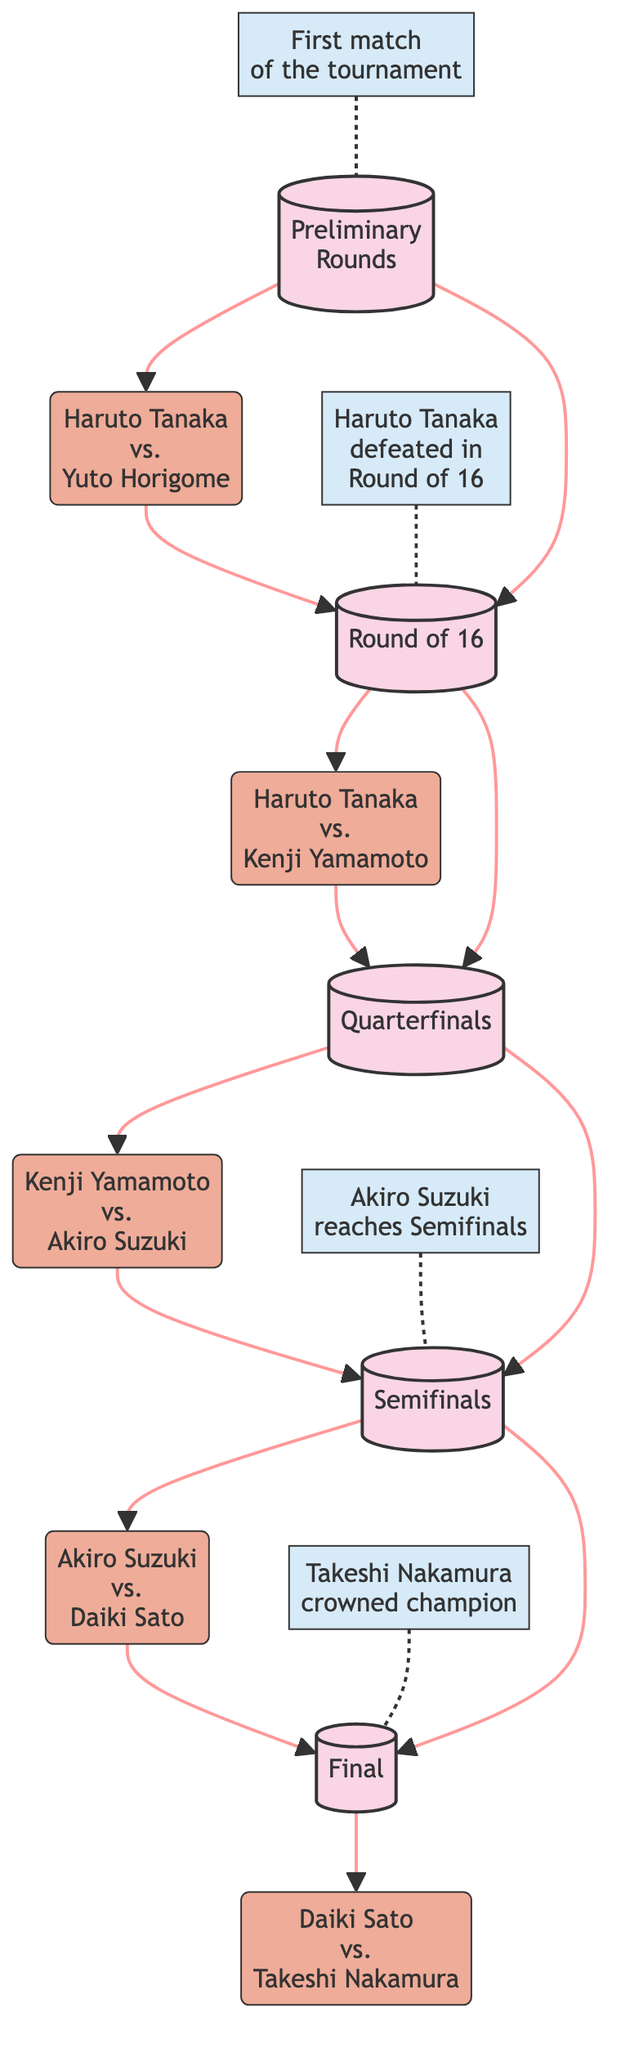What is the first match of the tournament? The diagram indicates that the first match is between Haruto Tanaka and Yuto Horigome, as shown at the start of the flowchart in the Preliminary Rounds section.
Answer: Haruto Tanaka vs. Yuto Horigome Which player was defeated in the Round of 16? According to the diagram, Haruto Tanaka was defeated in the Round of 16, as noted in the milestone connected to the Round of 16 stage.
Answer: Haruto Tanaka What stage comes after the Quarterfinals? The diagram clearly shows a progression from the Quarterfinals to the Semifinals, as indicated by the directional arrows connecting those stages.
Answer: Semifinals How many total matches are listed in the diagram? A count of the matches detailed in the diagram shows there are five matches represented, which can be tracked through the match nodes throughout the stages.
Answer: 5 Which player reached the Semifinals? The milestone within the Semifinals stage notes that Akiro Suzuki reached this round. By referring to the connections in the diagram, it's clear he progressed to this stage.
Answer: Akiro Suzuki Who was crowned champion of the tournament? The diagram specifies that Takeshi Nakamura was crowned champion, which is noted in the Final stage and is indicated as a milestone.
Answer: Takeshi Nakamura What are the total stages shown in the tournament progression? The diagram indicates five distinct stages: Preliminary Rounds, Round of 16, Quarterfinals, Semifinals, and Final, which can be counted from the stages listed at the beginning.
Answer: 5 Which match occurs in the Quarterfinals? The diagram shows that the match in the Quarterfinals involves Kenji Yamamoto and Akiro Suzuki, as displayed in the connection traveling from the Round of 16 to the Quarterfinals stage.
Answer: Kenji Yamamoto vs. Akiro Suzuki What was a key milestone in the Semifinals? The diagram indicates that a significant milestone in the Semifinals is Akiro Suzuki reaching this round, which is highlighted in the milestones connected to the Semifinals.
Answer: Akiro Suzuki reaches Semifinals 